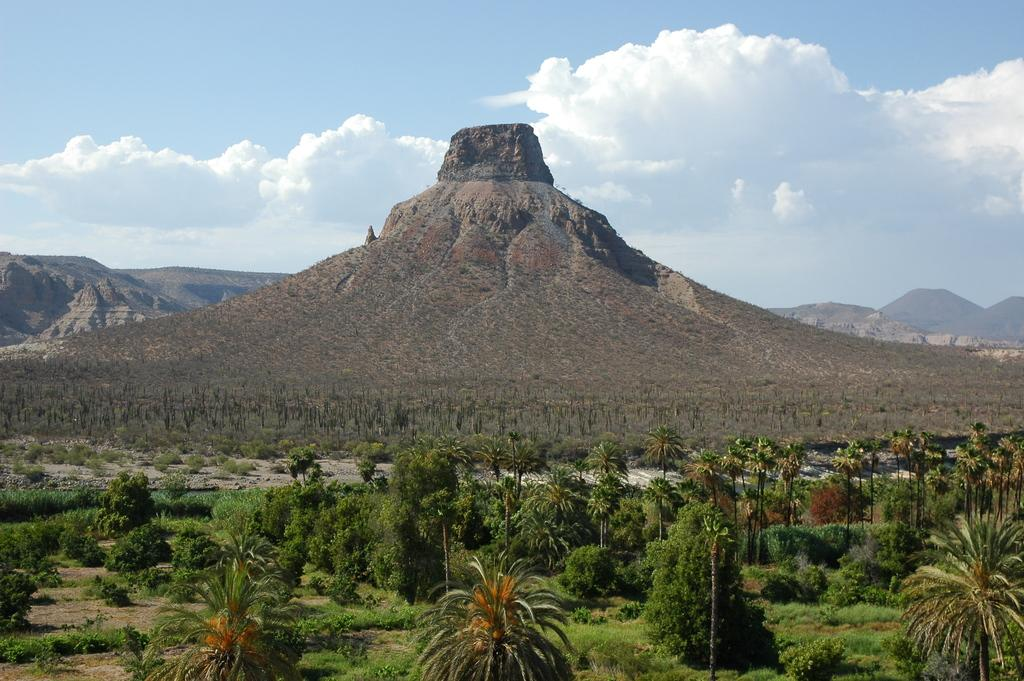What type of natural elements can be seen in the image? There are plants and mountains in the image. What part of the natural environment is visible in the image? The sky is visible in the image. What type of board can be seen in the image? There is no board present in the image. What type of garden can be seen in the image? There is no garden present in the image. 